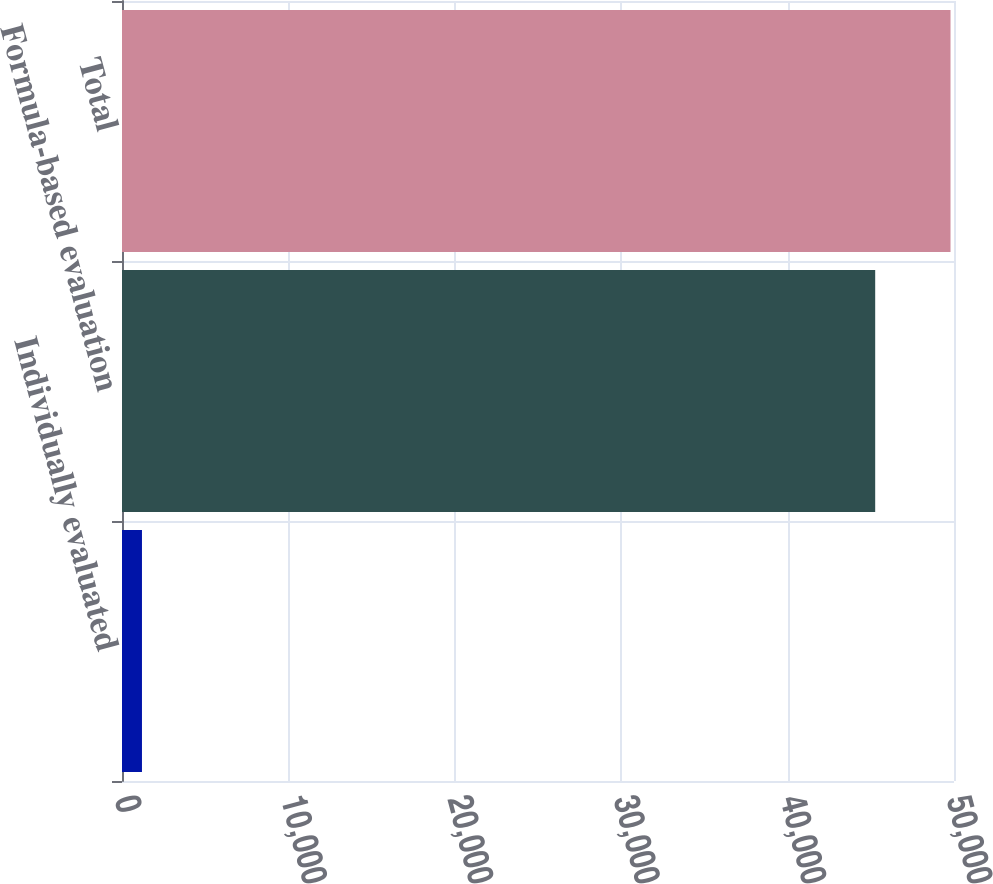Convert chart. <chart><loc_0><loc_0><loc_500><loc_500><bar_chart><fcel>Individually evaluated<fcel>Formula-based evaluation<fcel>Total<nl><fcel>1200<fcel>45264<fcel>49790.4<nl></chart> 